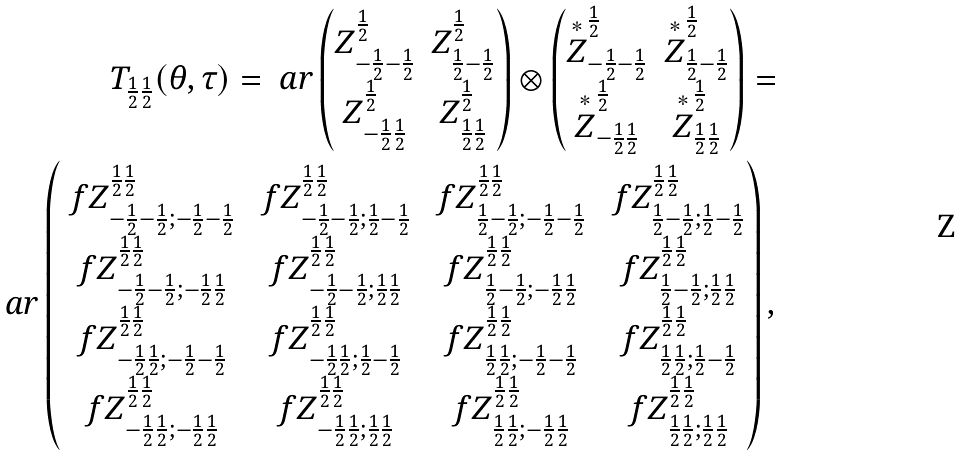<formula> <loc_0><loc_0><loc_500><loc_500>T _ { \frac { 1 } { 2 } \frac { 1 } { 2 } } ( \theta , \tau ) = \ a r \begin{pmatrix} Z ^ { \frac { 1 } { 2 } } _ { - \frac { 1 } { 2 } - \frac { 1 } { 2 } } & Z ^ { \frac { 1 } { 2 } } _ { \frac { 1 } { 2 } - \frac { 1 } { 2 } } \\ Z ^ { \frac { 1 } { 2 } } _ { - \frac { 1 } { 2 } \frac { 1 } { 2 } } & Z ^ { \frac { 1 } { 2 } } _ { \frac { 1 } { 2 } \frac { 1 } { 2 } } \end{pmatrix} \otimes \begin{pmatrix} \overset { \ast } { Z } ^ { \frac { 1 } { 2 } } _ { - \frac { 1 } { 2 } - \frac { 1 } { 2 } } & \overset { \ast } { Z } ^ { \frac { 1 } { 2 } } _ { \frac { 1 } { 2 } - \frac { 1 } { 2 } } \\ \overset { \ast } { Z } ^ { \frac { 1 } { 2 } } _ { - \frac { 1 } { 2 } \frac { 1 } { 2 } } & \overset { \ast } { Z } ^ { \frac { 1 } { 2 } } _ { \frac { 1 } { 2 } \frac { 1 } { 2 } } \end{pmatrix} = \\ \ a r \begin{pmatrix} \ f Z ^ { \frac { 1 } { 2 } \frac { 1 } { 2 } } _ { - \frac { 1 } { 2 } - \frac { 1 } { 2 } ; - \frac { 1 } { 2 } - \frac { 1 } { 2 } } & \ f Z ^ { \frac { 1 } { 2 } \frac { 1 } { 2 } } _ { - \frac { 1 } { 2 } - \frac { 1 } { 2 } ; \frac { 1 } { 2 } - \frac { 1 } { 2 } } & \ f Z ^ { \frac { 1 } { 2 } \frac { 1 } { 2 } } _ { \frac { 1 } { 2 } - \frac { 1 } { 2 } ; - \frac { 1 } { 2 } - \frac { 1 } { 2 } } & \ f Z ^ { \frac { 1 } { 2 } \frac { 1 } { 2 } } _ { \frac { 1 } { 2 } - \frac { 1 } { 2 } ; \frac { 1 } { 2 } - \frac { 1 } { 2 } } \\ \ f Z ^ { \frac { 1 } { 2 } \frac { 1 } { 2 } } _ { - \frac { 1 } { 2 } - \frac { 1 } { 2 } ; - \frac { 1 } { 2 } \frac { 1 } { 2 } } & \ f Z ^ { \frac { 1 } { 2 } \frac { 1 } { 2 } } _ { - \frac { 1 } { 2 } - \frac { 1 } { 2 } ; \frac { 1 } { 2 } \frac { 1 } { 2 } } & \ f Z ^ { \frac { 1 } { 2 } \frac { 1 } { 2 } } _ { \frac { 1 } { 2 } - \frac { 1 } { 2 } ; - \frac { 1 } { 2 } \frac { 1 } { 2 } } & \ f Z ^ { \frac { 1 } { 2 } \frac { 1 } { 2 } } _ { \frac { 1 } { 2 } - \frac { 1 } { 2 } ; \frac { 1 } { 2 } \frac { 1 } { 2 } } \\ \ f Z ^ { \frac { 1 } { 2 } \frac { 1 } { 2 } } _ { - \frac { 1 } { 2 } \frac { 1 } { 2 } ; - \frac { 1 } { 2 } - \frac { 1 } { 2 } } & \ f Z ^ { \frac { 1 } { 2 } \frac { 1 } { 2 } } _ { - \frac { 1 } { 2 } \frac { 1 } { 2 } ; \frac { 1 } { 2 } - \frac { 1 } { 2 } } & \ f Z ^ { \frac { 1 } { 2 } \frac { 1 } { 2 } } _ { \frac { 1 } { 2 } \frac { 1 } { 2 } ; - \frac { 1 } { 2 } - \frac { 1 } { 2 } } & \ f Z ^ { \frac { 1 } { 2 } \frac { 1 } { 2 } } _ { \frac { 1 } { 2 } \frac { 1 } { 2 } ; \frac { 1 } { 2 } - \frac { 1 } { 2 } } \\ \ f Z ^ { \frac { 1 } { 2 } \frac { 1 } { 2 } } _ { - \frac { 1 } { 2 } \frac { 1 } { 2 } ; - \frac { 1 } { 2 } \frac { 1 } { 2 } } & \ f Z ^ { \frac { 1 } { 2 } \frac { 1 } { 2 } } _ { - \frac { 1 } { 2 } \frac { 1 } { 2 } ; \frac { 1 } { 2 } \frac { 1 } { 2 } } & \ f Z ^ { \frac { 1 } { 2 } \frac { 1 } { 2 } } _ { \frac { 1 } { 2 } \frac { 1 } { 2 } ; - \frac { 1 } { 2 } \frac { 1 } { 2 } } & \ f Z ^ { \frac { 1 } { 2 } \frac { 1 } { 2 } } _ { \frac { 1 } { 2 } \frac { 1 } { 2 } ; \frac { 1 } { 2 } \frac { 1 } { 2 } } \end{pmatrix} ,</formula> 